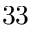Convert formula to latex. <formula><loc_0><loc_0><loc_500><loc_500>^ { 3 } 3</formula> 